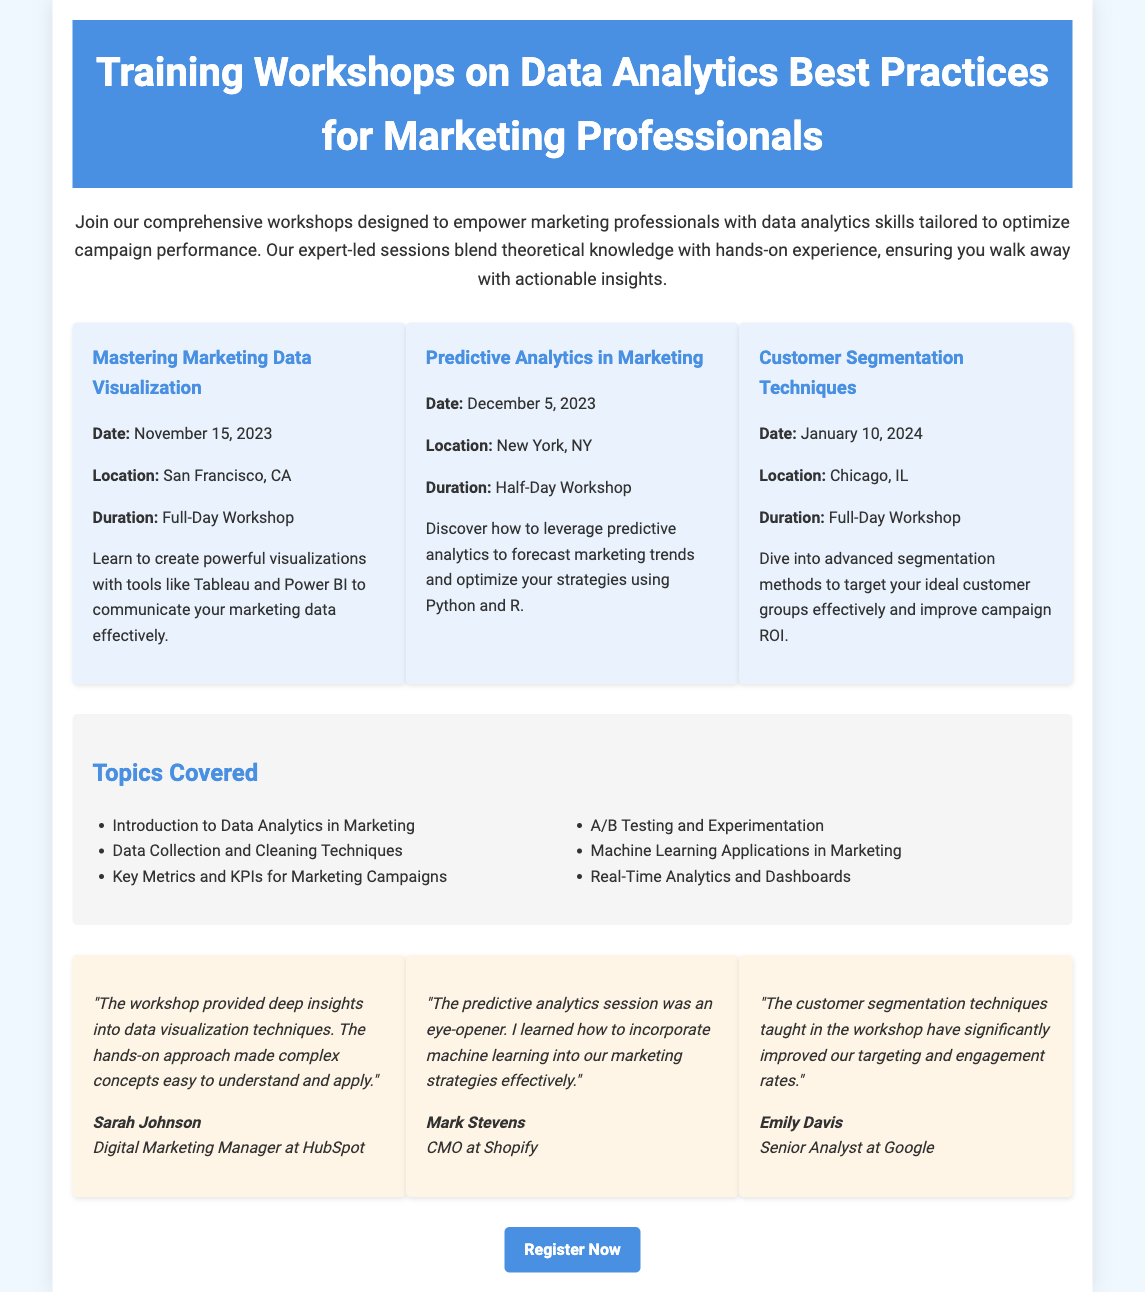What is the date of the workshop on Mastering Marketing Data Visualization? The date for this workshop is explicitly stated in the document.
Answer: November 15, 2023 What is the location of the Customer Segmentation Techniques workshop? The document provides specific locations for each workshop, and this is one of them.
Answer: Chicago, IL How long is the Predictive Analytics in Marketing workshop? The document specifies the duration for each workshop, indicating whether it is a full-day or half-day session.
Answer: Half-Day Workshop Who is a testimonial giver for the data visualization workshop? The document includes names of individuals who provided testimonials about the workshops, and one of them relates to this topic.
Answer: Sarah Johnson What are the two tools mentioned for data visualization? The document lists specific tools used in the workshop for creating visualizations, which gives insight into the workshop’s curriculum.
Answer: Tableau and Power BI What are the main topics covered in the workshops? The document has a section detailing various topics that will be covered across the different workshops.
Answer: Introduction to Data Analytics in Marketing, Data Collection and Cleaning Techniques, Key Metrics and KPIs for Marketing Campaigns, A/B Testing and Experimentation, Machine Learning Applications in Marketing, Real-Time Analytics and Dashboards How many workshops are listed in the document? The document outlines workshops and their details, allowing us to count them.
Answer: Three What is the link to register for the workshops? The document provides a specific call to action at the end, which includes the registration link for users to sign up.
Answer: https://www.example.com/data-analytics-workshops 